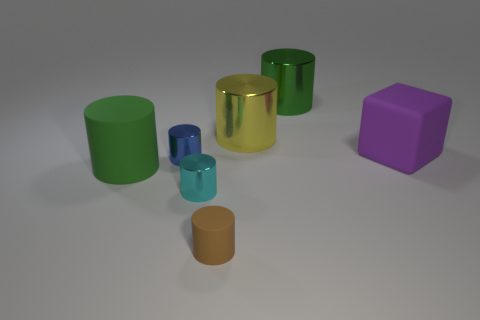Subtract all cyan cylinders. How many cylinders are left? 5 Subtract all tiny shiny cylinders. How many cylinders are left? 4 Subtract all brown cylinders. Subtract all brown spheres. How many cylinders are left? 5 Add 1 yellow cylinders. How many objects exist? 8 Subtract all cylinders. How many objects are left? 1 Subtract 0 cyan blocks. How many objects are left? 7 Subtract all brown balls. Subtract all purple objects. How many objects are left? 6 Add 5 small matte cylinders. How many small matte cylinders are left? 6 Add 6 large cyan things. How many large cyan things exist? 6 